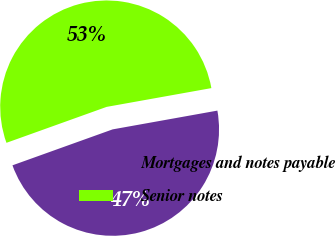Convert chart. <chart><loc_0><loc_0><loc_500><loc_500><pie_chart><fcel>Mortgages and notes payable<fcel>Senior notes<nl><fcel>47.34%<fcel>52.66%<nl></chart> 